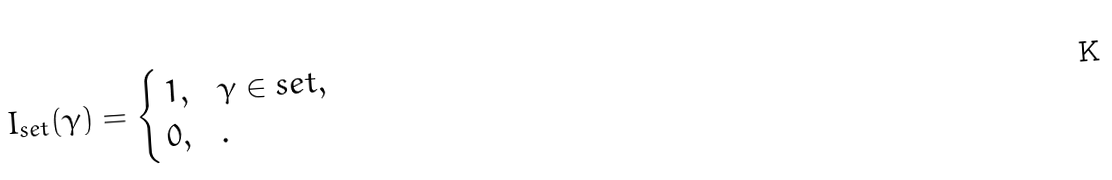<formula> <loc_0><loc_0><loc_500><loc_500>I _ { s e t } ( \gamma ) = \begin{cases} \, 1 , & \gamma \in s e t , \\ \, 0 , & . \end{cases}</formula> 